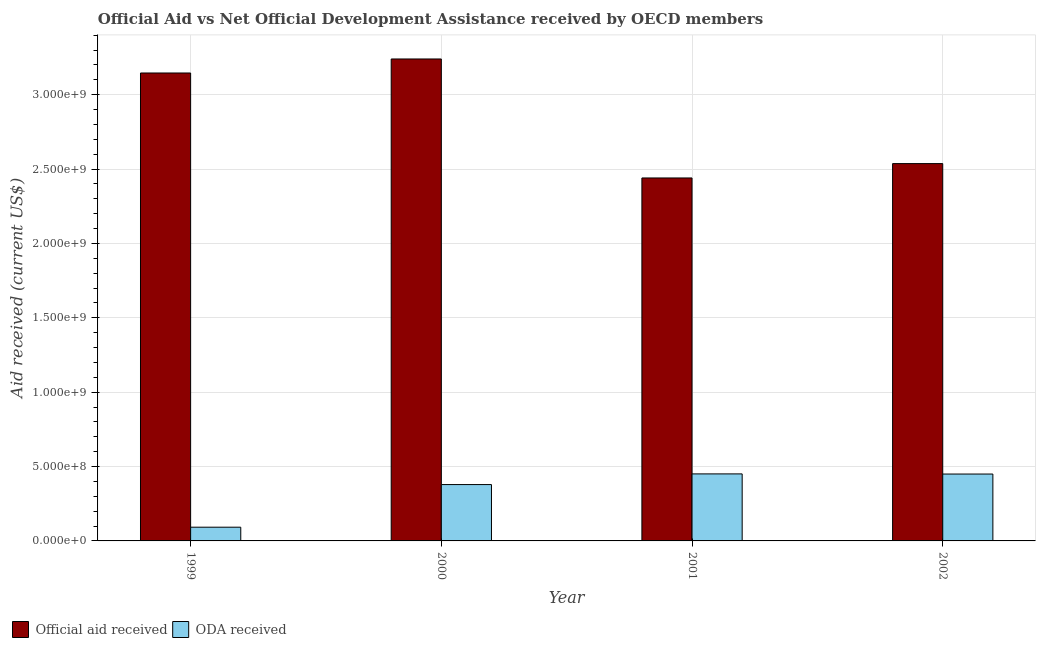How many different coloured bars are there?
Provide a short and direct response. 2. How many groups of bars are there?
Your answer should be compact. 4. How many bars are there on the 1st tick from the right?
Keep it short and to the point. 2. What is the label of the 4th group of bars from the left?
Ensure brevity in your answer.  2002. What is the official aid received in 2000?
Offer a very short reply. 3.24e+09. Across all years, what is the maximum official aid received?
Your response must be concise. 3.24e+09. Across all years, what is the minimum official aid received?
Provide a succinct answer. 2.44e+09. In which year was the official aid received minimum?
Keep it short and to the point. 2001. What is the total oda received in the graph?
Ensure brevity in your answer.  1.37e+09. What is the difference between the oda received in 2000 and that in 2001?
Provide a succinct answer. -7.18e+07. What is the difference between the oda received in 1999 and the official aid received in 2002?
Your response must be concise. -3.57e+08. What is the average official aid received per year?
Provide a succinct answer. 2.84e+09. In how many years, is the oda received greater than 1500000000 US$?
Make the answer very short. 0. What is the ratio of the official aid received in 1999 to that in 2001?
Keep it short and to the point. 1.29. Is the oda received in 2000 less than that in 2001?
Provide a short and direct response. Yes. What is the difference between the highest and the second highest oda received?
Your answer should be very brief. 9.30e+05. What is the difference between the highest and the lowest oda received?
Make the answer very short. 3.58e+08. In how many years, is the oda received greater than the average oda received taken over all years?
Make the answer very short. 3. What does the 2nd bar from the left in 2000 represents?
Your response must be concise. ODA received. What does the 2nd bar from the right in 1999 represents?
Offer a very short reply. Official aid received. Are all the bars in the graph horizontal?
Ensure brevity in your answer.  No. How many years are there in the graph?
Offer a terse response. 4. Are the values on the major ticks of Y-axis written in scientific E-notation?
Keep it short and to the point. Yes. Does the graph contain grids?
Your response must be concise. Yes. What is the title of the graph?
Make the answer very short. Official Aid vs Net Official Development Assistance received by OECD members . Does "Lower secondary rate" appear as one of the legend labels in the graph?
Ensure brevity in your answer.  No. What is the label or title of the X-axis?
Ensure brevity in your answer.  Year. What is the label or title of the Y-axis?
Offer a terse response. Aid received (current US$). What is the Aid received (current US$) of Official aid received in 1999?
Ensure brevity in your answer.  3.15e+09. What is the Aid received (current US$) of ODA received in 1999?
Make the answer very short. 9.23e+07. What is the Aid received (current US$) of Official aid received in 2000?
Provide a short and direct response. 3.24e+09. What is the Aid received (current US$) of ODA received in 2000?
Offer a very short reply. 3.79e+08. What is the Aid received (current US$) in Official aid received in 2001?
Offer a very short reply. 2.44e+09. What is the Aid received (current US$) of ODA received in 2001?
Provide a succinct answer. 4.51e+08. What is the Aid received (current US$) of Official aid received in 2002?
Keep it short and to the point. 2.54e+09. What is the Aid received (current US$) of ODA received in 2002?
Ensure brevity in your answer.  4.50e+08. Across all years, what is the maximum Aid received (current US$) in Official aid received?
Provide a succinct answer. 3.24e+09. Across all years, what is the maximum Aid received (current US$) in ODA received?
Your answer should be very brief. 4.51e+08. Across all years, what is the minimum Aid received (current US$) of Official aid received?
Offer a terse response. 2.44e+09. Across all years, what is the minimum Aid received (current US$) of ODA received?
Keep it short and to the point. 9.23e+07. What is the total Aid received (current US$) of Official aid received in the graph?
Your answer should be compact. 1.14e+1. What is the total Aid received (current US$) in ODA received in the graph?
Your answer should be compact. 1.37e+09. What is the difference between the Aid received (current US$) in Official aid received in 1999 and that in 2000?
Provide a short and direct response. -9.42e+07. What is the difference between the Aid received (current US$) in ODA received in 1999 and that in 2000?
Make the answer very short. -2.87e+08. What is the difference between the Aid received (current US$) of Official aid received in 1999 and that in 2001?
Ensure brevity in your answer.  7.06e+08. What is the difference between the Aid received (current US$) of ODA received in 1999 and that in 2001?
Your answer should be very brief. -3.58e+08. What is the difference between the Aid received (current US$) in Official aid received in 1999 and that in 2002?
Your answer should be very brief. 6.09e+08. What is the difference between the Aid received (current US$) in ODA received in 1999 and that in 2002?
Provide a short and direct response. -3.57e+08. What is the difference between the Aid received (current US$) in Official aid received in 2000 and that in 2001?
Provide a succinct answer. 8.00e+08. What is the difference between the Aid received (current US$) in ODA received in 2000 and that in 2001?
Your response must be concise. -7.18e+07. What is the difference between the Aid received (current US$) in Official aid received in 2000 and that in 2002?
Keep it short and to the point. 7.03e+08. What is the difference between the Aid received (current US$) in ODA received in 2000 and that in 2002?
Give a very brief answer. -7.08e+07. What is the difference between the Aid received (current US$) in Official aid received in 2001 and that in 2002?
Ensure brevity in your answer.  -9.66e+07. What is the difference between the Aid received (current US$) in ODA received in 2001 and that in 2002?
Make the answer very short. 9.30e+05. What is the difference between the Aid received (current US$) of Official aid received in 1999 and the Aid received (current US$) of ODA received in 2000?
Give a very brief answer. 2.77e+09. What is the difference between the Aid received (current US$) of Official aid received in 1999 and the Aid received (current US$) of ODA received in 2001?
Give a very brief answer. 2.70e+09. What is the difference between the Aid received (current US$) of Official aid received in 1999 and the Aid received (current US$) of ODA received in 2002?
Keep it short and to the point. 2.70e+09. What is the difference between the Aid received (current US$) of Official aid received in 2000 and the Aid received (current US$) of ODA received in 2001?
Provide a succinct answer. 2.79e+09. What is the difference between the Aid received (current US$) in Official aid received in 2000 and the Aid received (current US$) in ODA received in 2002?
Your answer should be compact. 2.79e+09. What is the difference between the Aid received (current US$) of Official aid received in 2001 and the Aid received (current US$) of ODA received in 2002?
Give a very brief answer. 1.99e+09. What is the average Aid received (current US$) of Official aid received per year?
Offer a very short reply. 2.84e+09. What is the average Aid received (current US$) in ODA received per year?
Offer a very short reply. 3.43e+08. In the year 1999, what is the difference between the Aid received (current US$) in Official aid received and Aid received (current US$) in ODA received?
Ensure brevity in your answer.  3.05e+09. In the year 2000, what is the difference between the Aid received (current US$) in Official aid received and Aid received (current US$) in ODA received?
Provide a succinct answer. 2.86e+09. In the year 2001, what is the difference between the Aid received (current US$) of Official aid received and Aid received (current US$) of ODA received?
Give a very brief answer. 1.99e+09. In the year 2002, what is the difference between the Aid received (current US$) in Official aid received and Aid received (current US$) in ODA received?
Offer a very short reply. 2.09e+09. What is the ratio of the Aid received (current US$) in Official aid received in 1999 to that in 2000?
Your answer should be very brief. 0.97. What is the ratio of the Aid received (current US$) of ODA received in 1999 to that in 2000?
Your answer should be compact. 0.24. What is the ratio of the Aid received (current US$) in Official aid received in 1999 to that in 2001?
Provide a succinct answer. 1.29. What is the ratio of the Aid received (current US$) of ODA received in 1999 to that in 2001?
Ensure brevity in your answer.  0.2. What is the ratio of the Aid received (current US$) of Official aid received in 1999 to that in 2002?
Your answer should be compact. 1.24. What is the ratio of the Aid received (current US$) in ODA received in 1999 to that in 2002?
Give a very brief answer. 0.21. What is the ratio of the Aid received (current US$) in Official aid received in 2000 to that in 2001?
Your answer should be very brief. 1.33. What is the ratio of the Aid received (current US$) in ODA received in 2000 to that in 2001?
Your answer should be compact. 0.84. What is the ratio of the Aid received (current US$) in Official aid received in 2000 to that in 2002?
Give a very brief answer. 1.28. What is the ratio of the Aid received (current US$) of ODA received in 2000 to that in 2002?
Provide a short and direct response. 0.84. What is the ratio of the Aid received (current US$) in Official aid received in 2001 to that in 2002?
Offer a very short reply. 0.96. What is the difference between the highest and the second highest Aid received (current US$) of Official aid received?
Offer a very short reply. 9.42e+07. What is the difference between the highest and the second highest Aid received (current US$) in ODA received?
Offer a terse response. 9.30e+05. What is the difference between the highest and the lowest Aid received (current US$) in Official aid received?
Offer a terse response. 8.00e+08. What is the difference between the highest and the lowest Aid received (current US$) of ODA received?
Offer a terse response. 3.58e+08. 